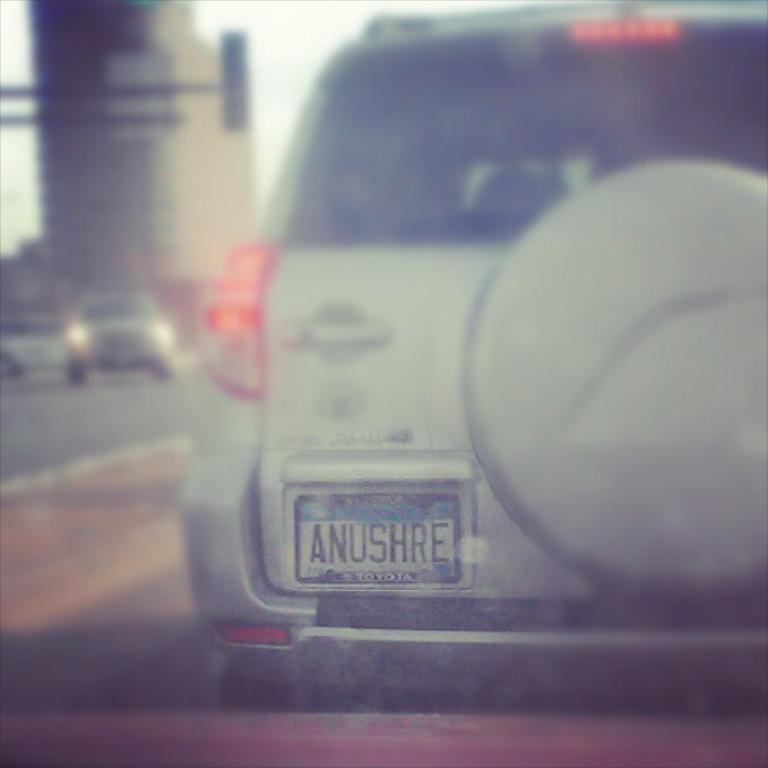Provide a one-sentence caption for the provided image. A plate that has the letters ANUSHRE on it. 